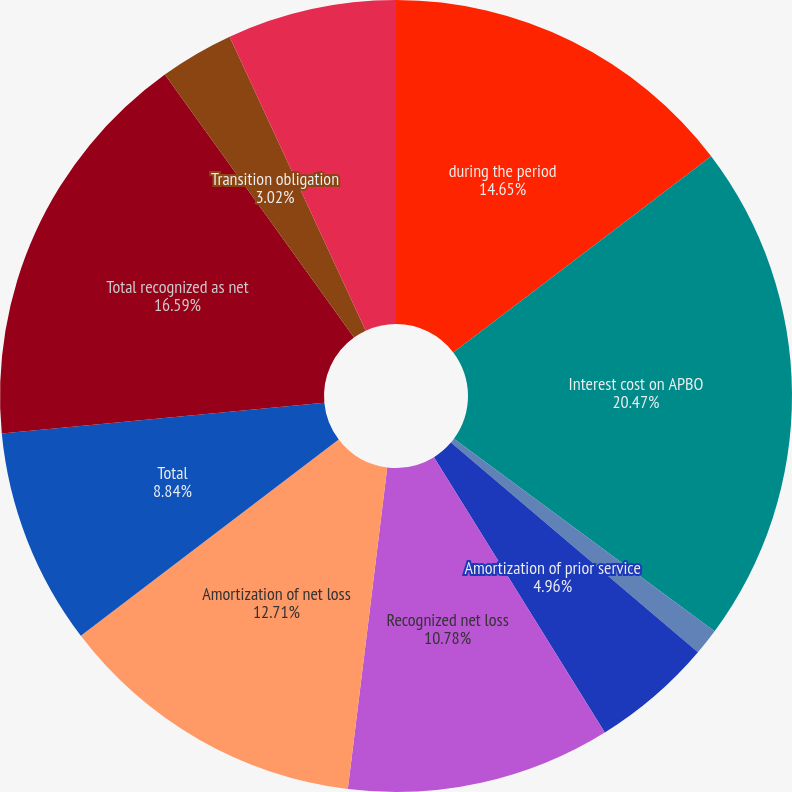<chart> <loc_0><loc_0><loc_500><loc_500><pie_chart><fcel>during the period<fcel>Interest cost on APBO<fcel>Amortization of transition<fcel>Amortization of prior service<fcel>Recognized net loss<fcel>Amortization of net loss<fcel>Total<fcel>Total recognized as net<fcel>Transition obligation<fcel>Prior service cost/(credit)<nl><fcel>14.65%<fcel>20.47%<fcel>1.08%<fcel>4.96%<fcel>10.78%<fcel>12.71%<fcel>8.84%<fcel>16.59%<fcel>3.02%<fcel>6.9%<nl></chart> 